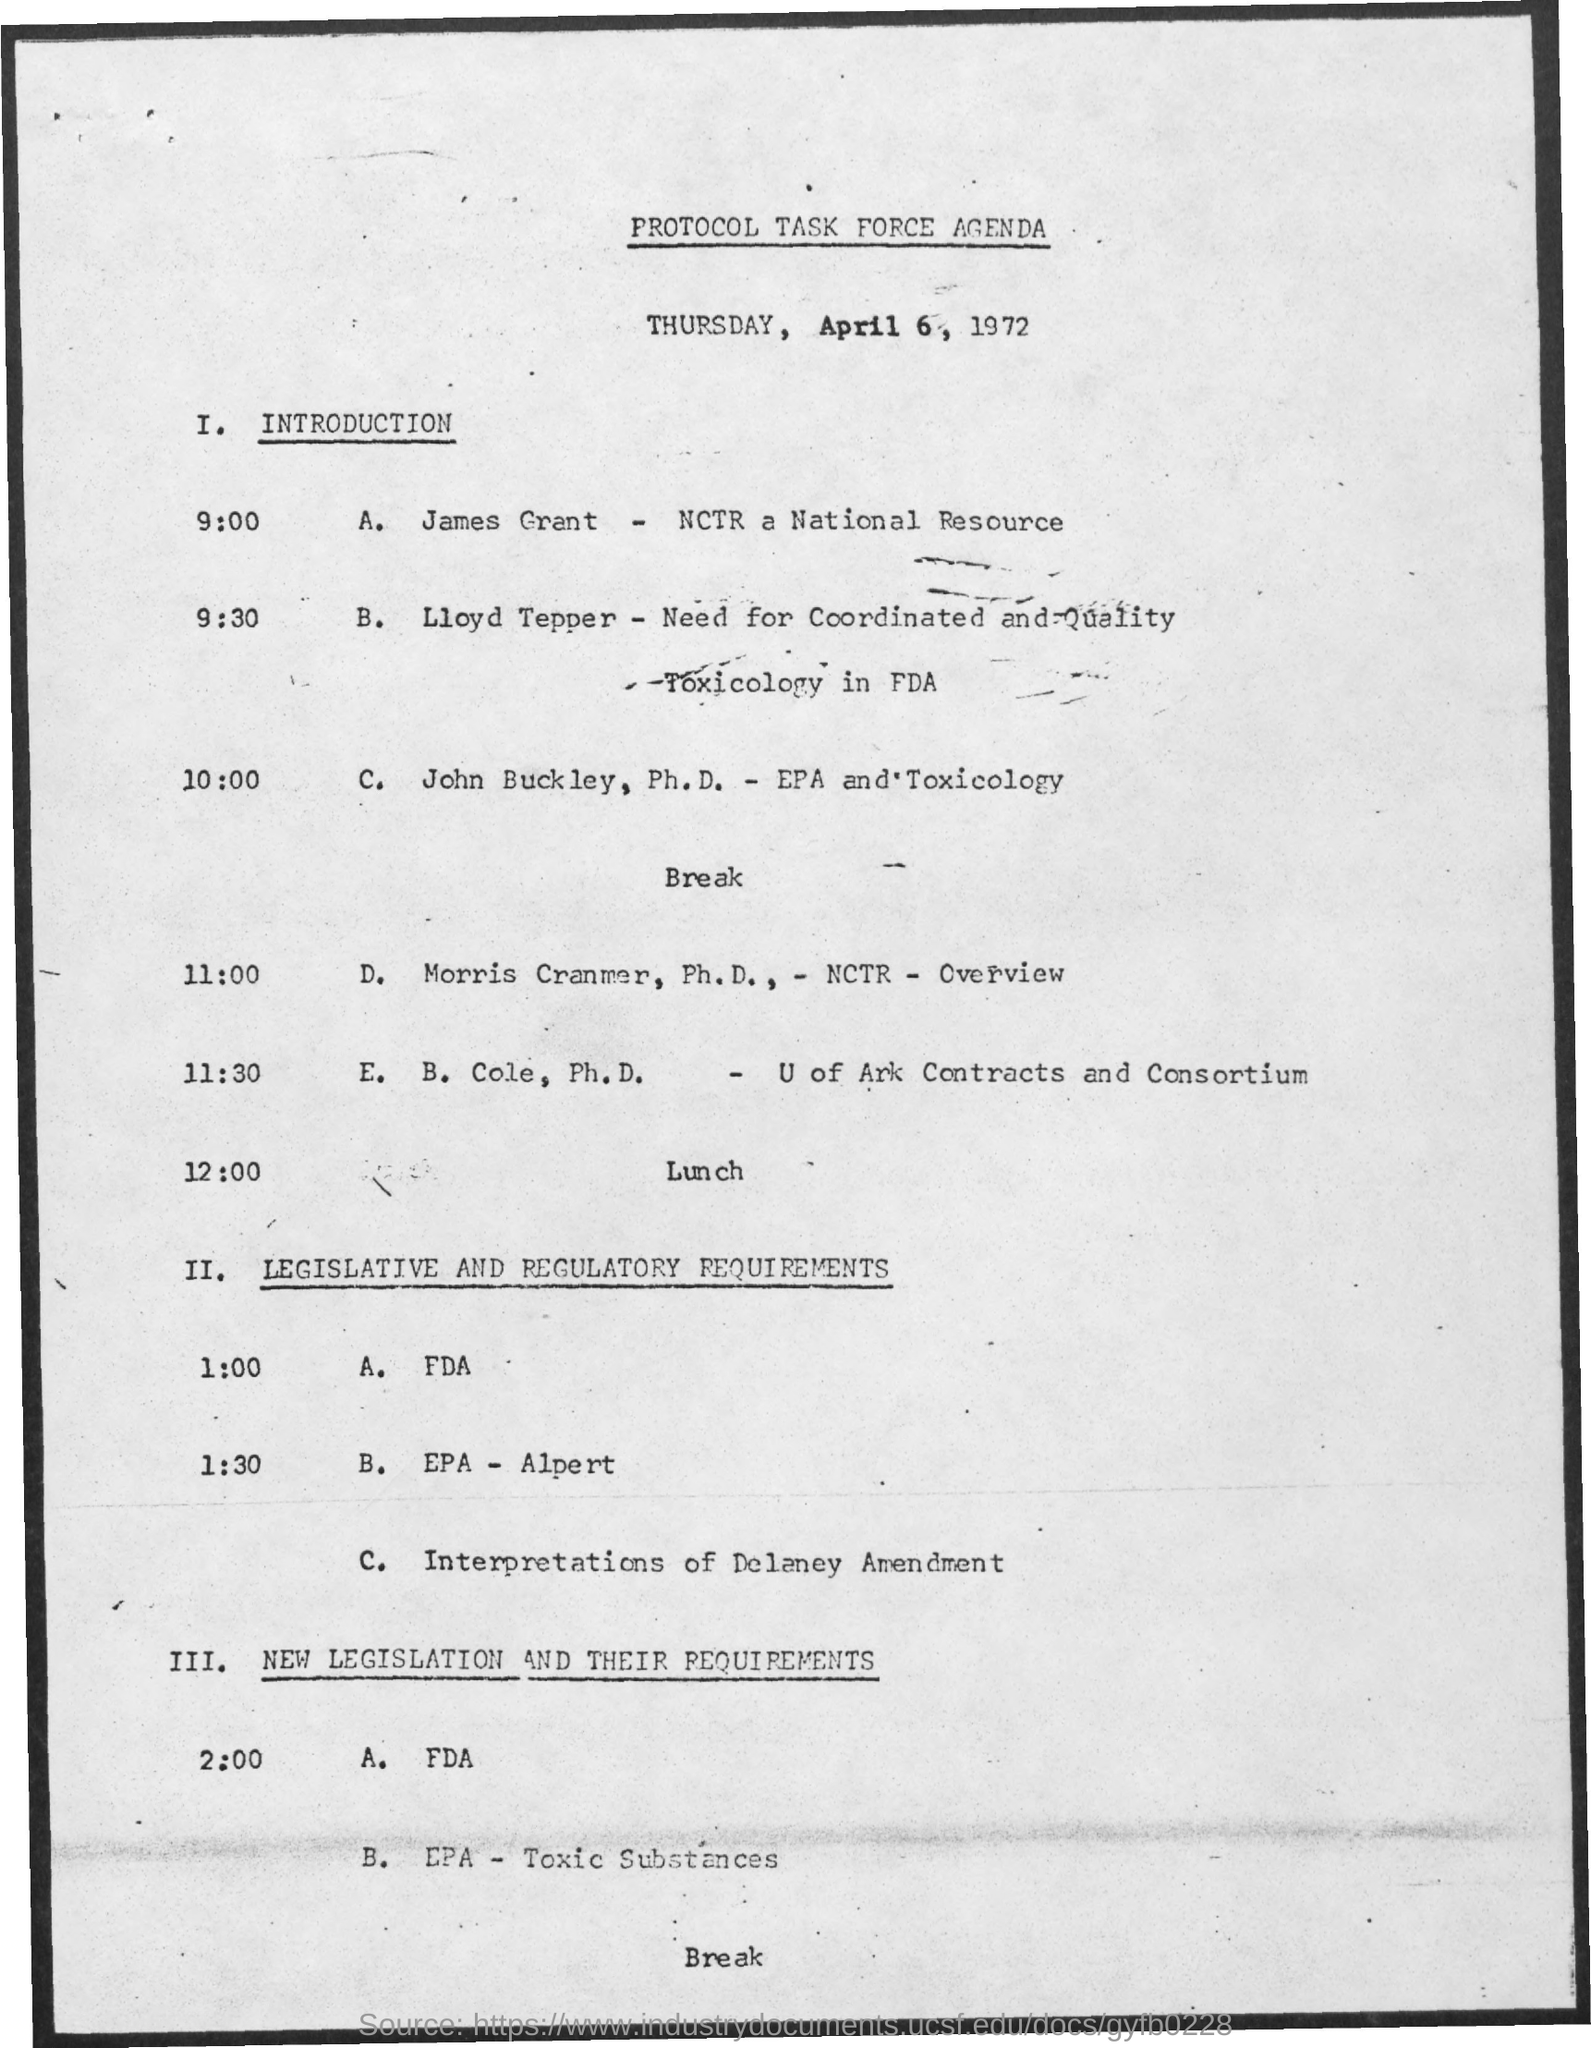What is the title of the document?
Your answer should be compact. Protocol task force agenda. John Buckley holds Ph.D. in which subject?
Provide a succinct answer. Epa and toxicology. 